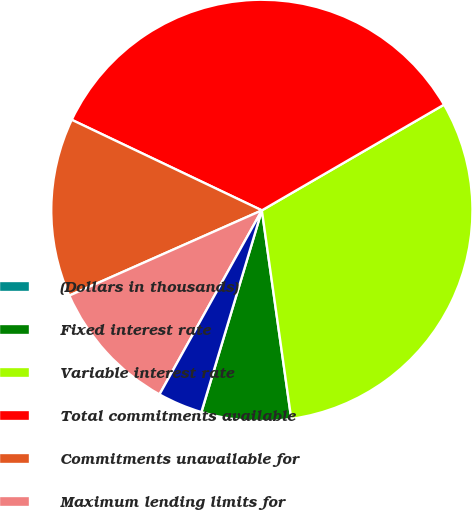Convert chart. <chart><loc_0><loc_0><loc_500><loc_500><pie_chart><fcel>(Dollars in thousands)<fcel>Fixed interest rate<fcel>Variable interest rate<fcel>Total commitments available<fcel>Commitments unavailable for<fcel>Maximum lending limits for<fcel>Reserve for unfunded credit<nl><fcel>0.01%<fcel>6.86%<fcel>31.14%<fcel>34.56%<fcel>13.71%<fcel>10.29%<fcel>3.44%<nl></chart> 